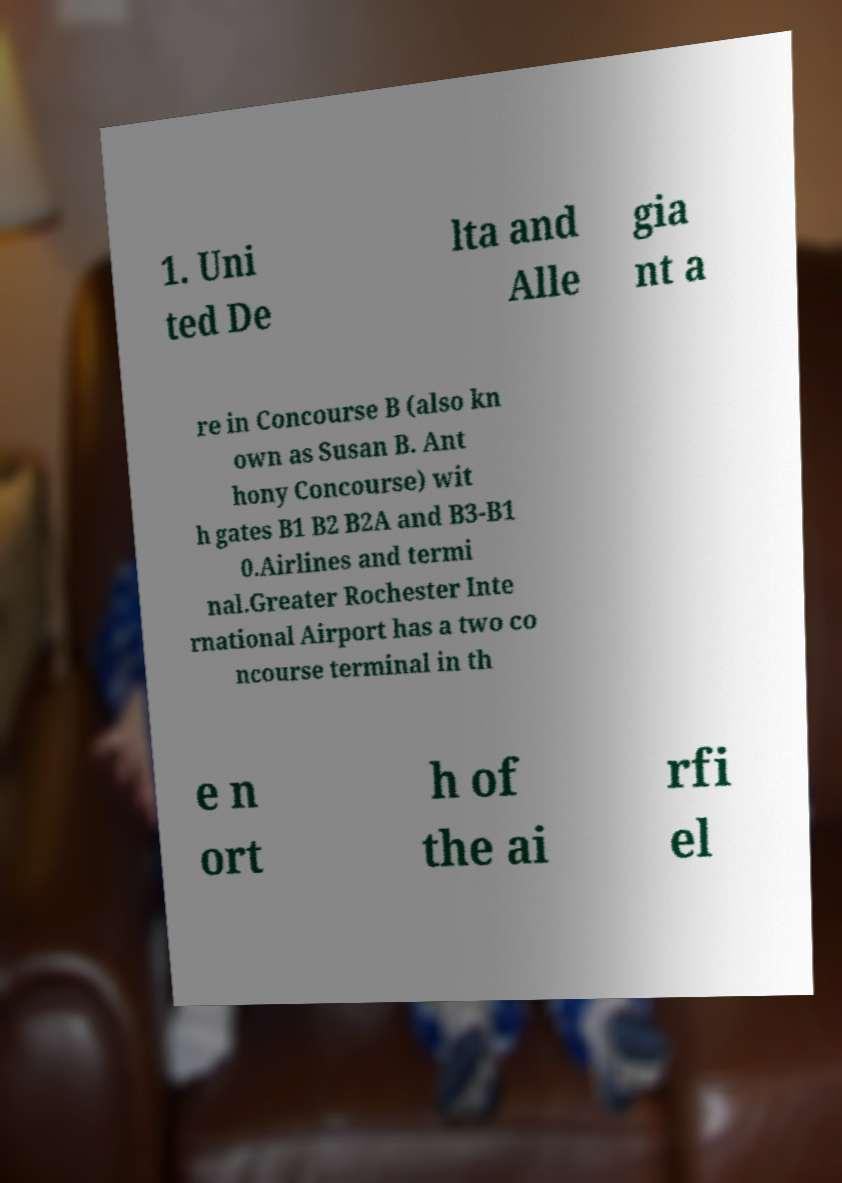I need the written content from this picture converted into text. Can you do that? 1. Uni ted De lta and Alle gia nt a re in Concourse B (also kn own as Susan B. Ant hony Concourse) wit h gates B1 B2 B2A and B3-B1 0.Airlines and termi nal.Greater Rochester Inte rnational Airport has a two co ncourse terminal in th e n ort h of the ai rfi el 